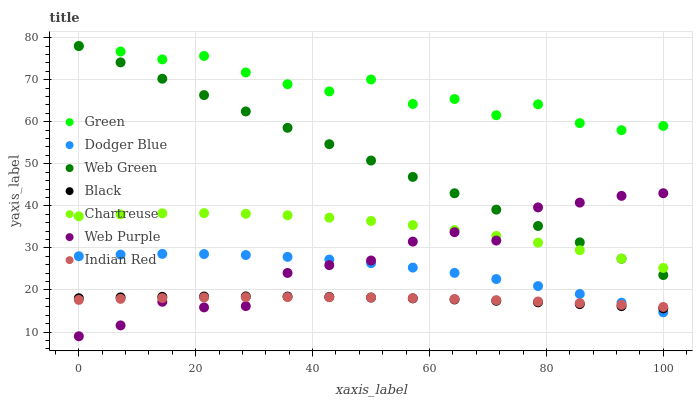Does Indian Red have the minimum area under the curve?
Answer yes or no. Yes. Does Green have the maximum area under the curve?
Answer yes or no. Yes. Does Web Purple have the minimum area under the curve?
Answer yes or no. No. Does Web Purple have the maximum area under the curve?
Answer yes or no. No. Is Web Green the smoothest?
Answer yes or no. Yes. Is Green the roughest?
Answer yes or no. Yes. Is Web Purple the smoothest?
Answer yes or no. No. Is Web Purple the roughest?
Answer yes or no. No. Does Web Purple have the lowest value?
Answer yes or no. Yes. Does Web Green have the lowest value?
Answer yes or no. No. Does Green have the highest value?
Answer yes or no. Yes. Does Web Purple have the highest value?
Answer yes or no. No. Is Black less than Green?
Answer yes or no. Yes. Is Green greater than Chartreuse?
Answer yes or no. Yes. Does Dodger Blue intersect Indian Red?
Answer yes or no. Yes. Is Dodger Blue less than Indian Red?
Answer yes or no. No. Is Dodger Blue greater than Indian Red?
Answer yes or no. No. Does Black intersect Green?
Answer yes or no. No. 